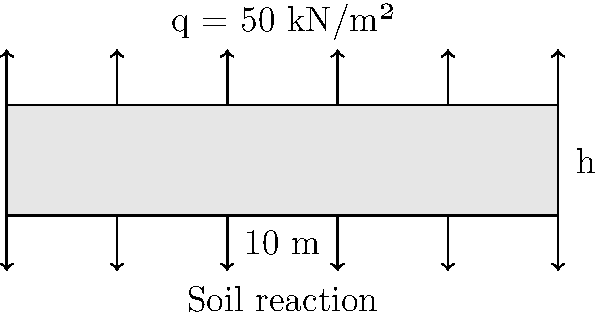As a family business owner expanding your operations, you're planning to construct a new warehouse. The concrete floor slab needs to support heavy machinery and storage. Given a uniformly distributed load of 50 kN/m² and a soil bearing capacity of 200 kN/m², calculate the minimum required thickness of the concrete slab. Assume the concrete's flexural strength is 4 MPa and use a safety factor of 1.5. The slab spans 10 meters between supports. To calculate the minimum required thickness of the concrete slab, we'll follow these steps:

1. Calculate the maximum bending moment:
   The maximum bending moment for a uniformly distributed load occurs at the center of the span.
   $$M_{max} = \frac{qL^2}{8}$$
   where q is the distributed load and L is the span length.
   $$M_{max} = \frac{50 \text{ kN/m²} \times (10 \text{ m})^2}{8} = 625 \text{ kN⋅m/m}$$

2. Determine the required section modulus:
   $$S_{req} = \frac{M_{max}}{\sigma_{allow}}$$
   where $\sigma_{allow}$ is the allowable stress (flexural strength / safety factor).
   $$S_{req} = \frac{625 \text{ kN⋅m/m}}{(4000 \text{ kN/m²} / 1.5)} = 0.234375 \text{ m³/m}$$

3. Calculate the required thickness:
   For a rectangular section, $S = \frac{bh^2}{6}$, where b is the width (1 m for per meter calculation) and h is the thickness.
   $$h = \sqrt{\frac{6S_{req}}{b}} = \sqrt{\frac{6 \times 0.234375 \text{ m³/m}}{1 \text{ m}}} = 1.185 \text{ m}$$

4. Check if the soil can support the load:
   Total load = Slab weight + Distributed load
   $$q_{total} = (1.185 \text{ m} \times 25 \text{ kN/m³}) + 50 \text{ kN/m²} = 79.625 \text{ kN/m²}$$
   This is less than the soil bearing capacity of 200 kN/m², so the design is acceptable.

5. Round up to the nearest practical dimension:
   The minimum required thickness should be rounded up to 1.2 m for practical construction purposes.
Answer: 1.2 m 